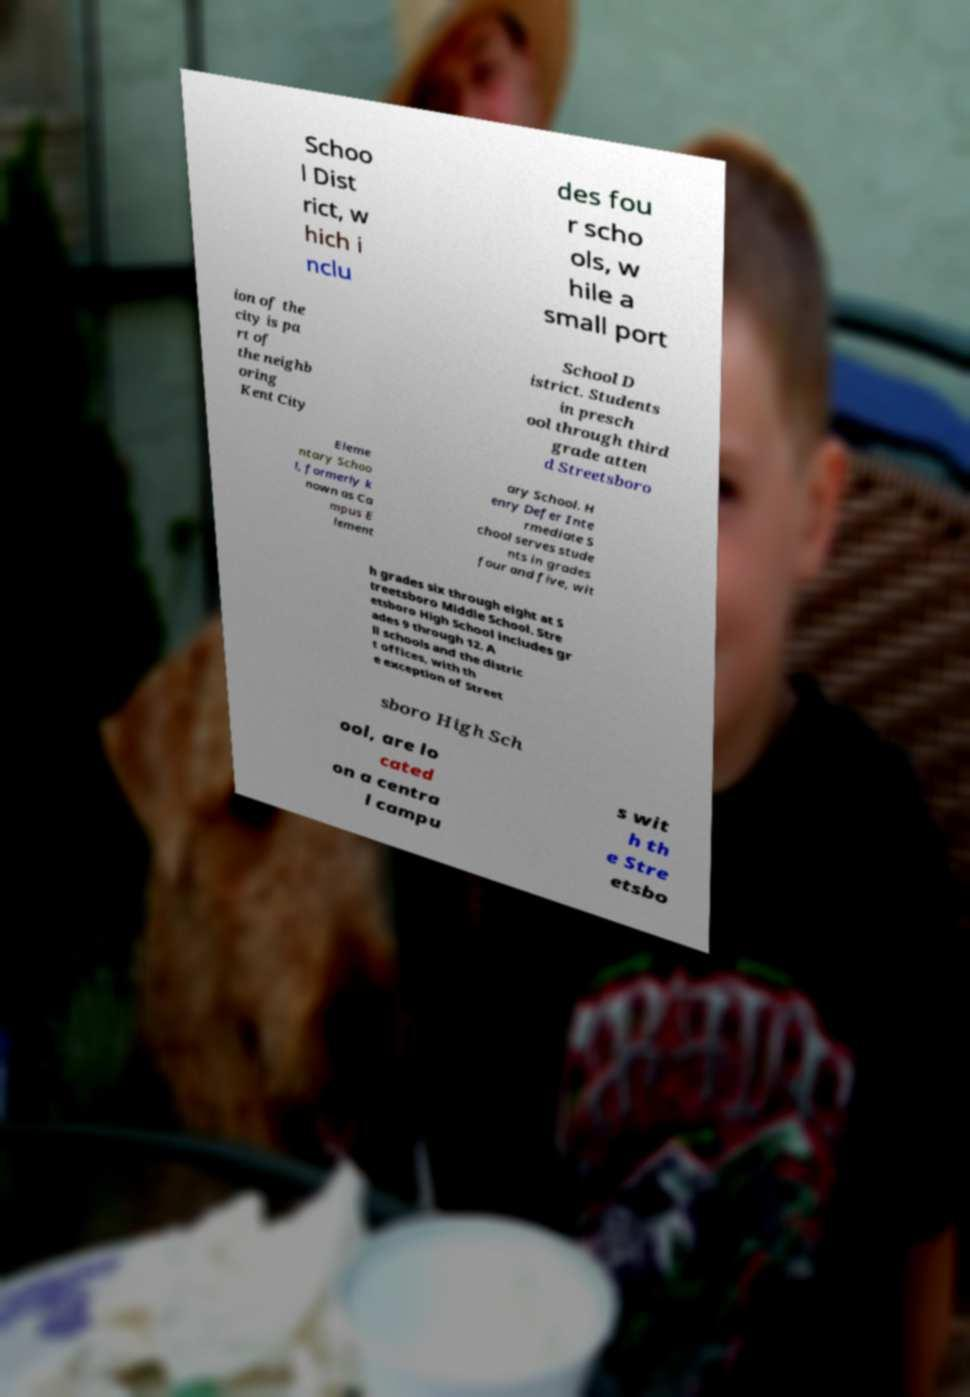Please identify and transcribe the text found in this image. Schoo l Dist rict, w hich i nclu des fou r scho ols, w hile a small port ion of the city is pa rt of the neighb oring Kent City School D istrict. Students in presch ool through third grade atten d Streetsboro Eleme ntary Schoo l, formerly k nown as Ca mpus E lement ary School. H enry Defer Inte rmediate S chool serves stude nts in grades four and five, wit h grades six through eight at S treetsboro Middle School. Stre etsboro High School includes gr ades 9 through 12. A ll schools and the distric t offices, with th e exception of Street sboro High Sch ool, are lo cated on a centra l campu s wit h th e Stre etsbo 